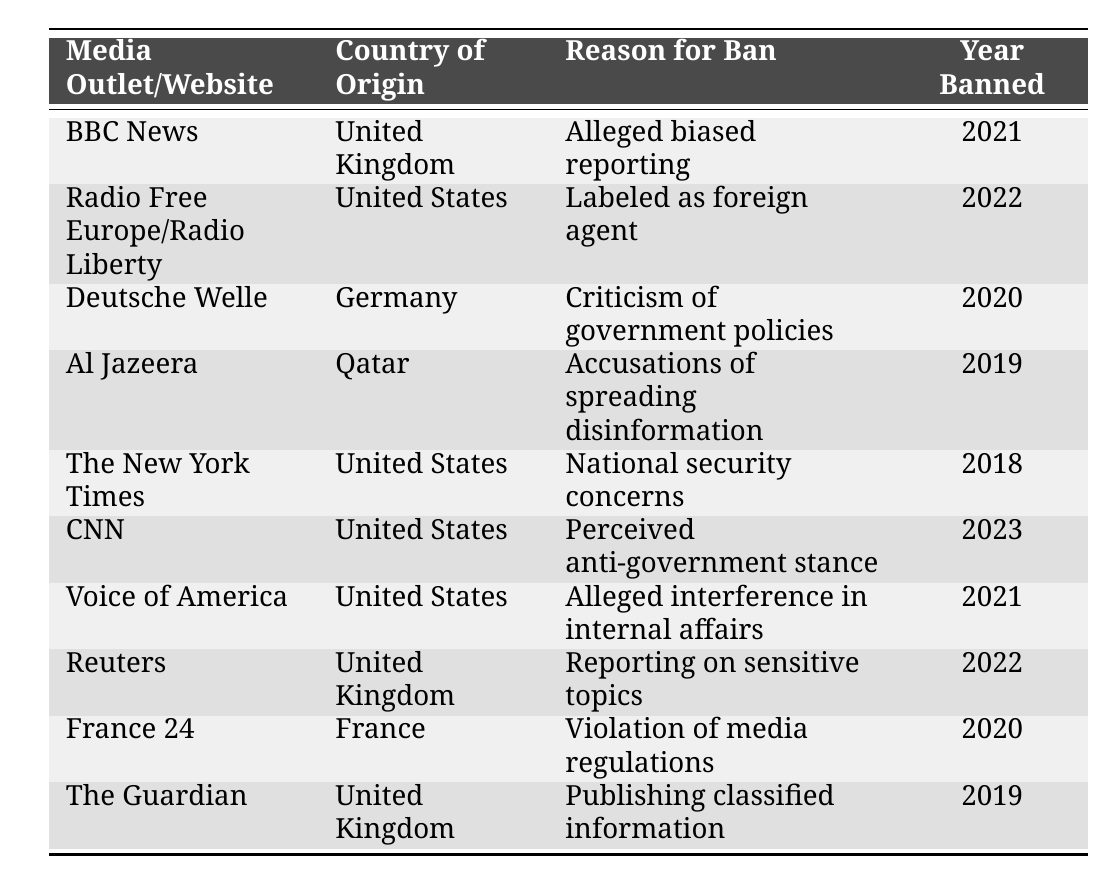What is the reason for banning BBC News? According to the table, BBC News was banned due to "Alleged biased reporting."
Answer: Alleged biased reporting How many media outlets are banned from the United States? By counting the entries in the table, there are four media outlets originating from the United States that are banned: Radio Free Europe/Radio Liberty, The New York Times, CNN, and Voice of America.
Answer: 4 Did France 24 get banned in 2021? According to the table, France 24 was banned in 2020, not in 2021.
Answer: No Which media outlet was banned for publishing classified information? Referring to the table, The Guardian was banned for "Publishing classified information."
Answer: The Guardian What year did Al Jazeera get banned? The table indicates that Al Jazeera was banned in 2019.
Answer: 2019 How many media outlets were banned in the year 2022? The table lists two media outlets banned in 2022: Radio Free Europe/Radio Liberty and Reuters. Therefore, the count is two.
Answer: 2 Was any media outlet banned specifically for “violations of media regulations”? Yes, the table shows that France 24 was banned for "Violation of media regulations."
Answer: Yes Which country had the most media outlets banned? The United States had the most with four banned media outlets: Radio Free Europe/Radio Liberty, The New York Times, CNN, and Voice of America.
Answer: United States 